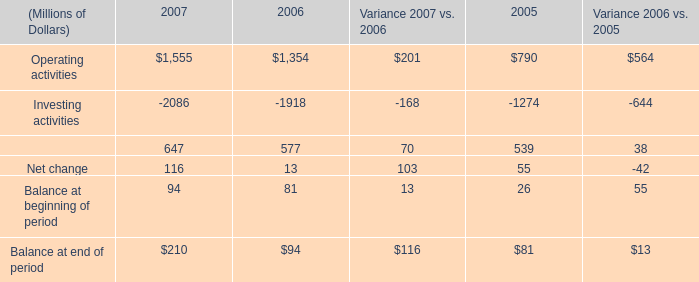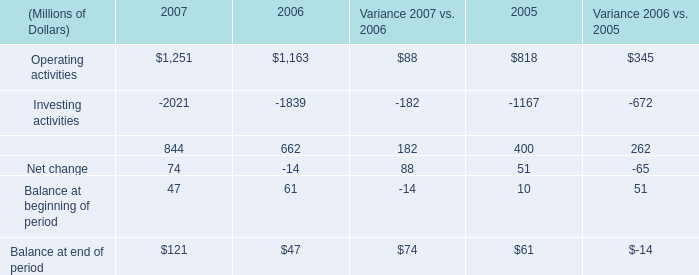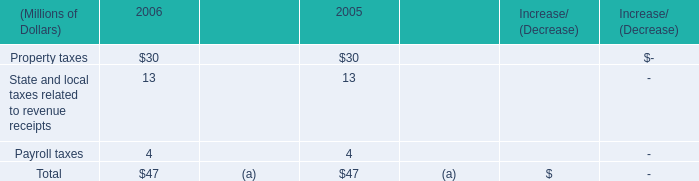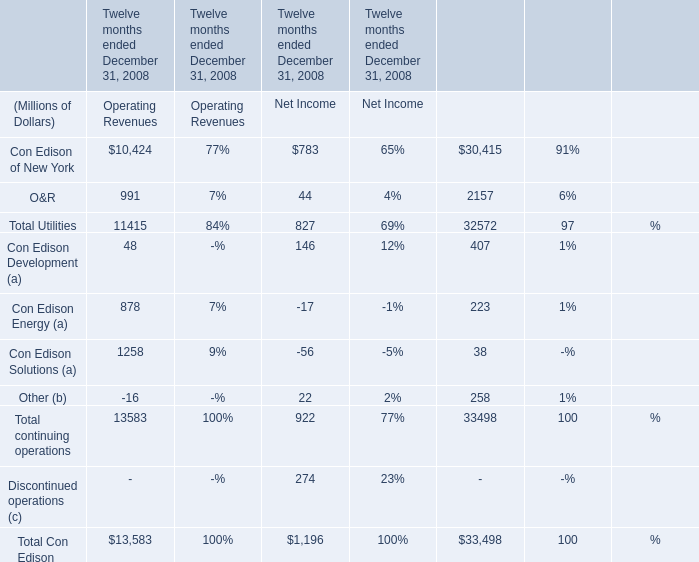What is the ratio of all elements that are smaller than 200 to the sum of elements in Net Income? 
Computations: (((((44 - 17) - 56) + 22) + 146) / 1196)
Answer: 0.11622. 